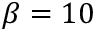Convert formula to latex. <formula><loc_0><loc_0><loc_500><loc_500>\beta = 1 0</formula> 